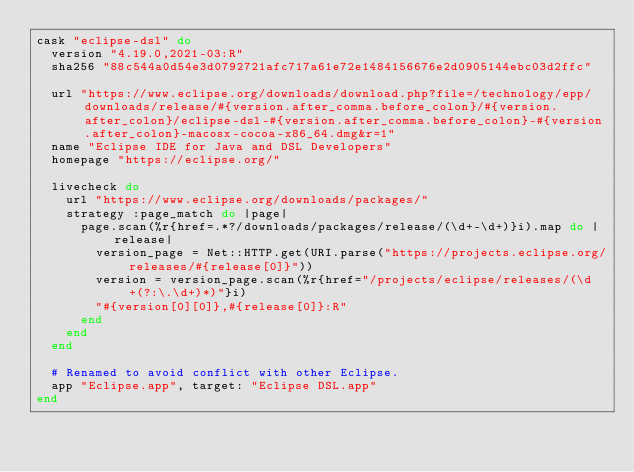Convert code to text. <code><loc_0><loc_0><loc_500><loc_500><_Ruby_>cask "eclipse-dsl" do
  version "4.19.0,2021-03:R"
  sha256 "88c544a0d54e3d0792721afc717a61e72e1484156676e2d0905144ebc03d2ffc"

  url "https://www.eclipse.org/downloads/download.php?file=/technology/epp/downloads/release/#{version.after_comma.before_colon}/#{version.after_colon}/eclipse-dsl-#{version.after_comma.before_colon}-#{version.after_colon}-macosx-cocoa-x86_64.dmg&r=1"
  name "Eclipse IDE for Java and DSL Developers"
  homepage "https://eclipse.org/"

  livecheck do
    url "https://www.eclipse.org/downloads/packages/"
    strategy :page_match do |page|
      page.scan(%r{href=.*?/downloads/packages/release/(\d+-\d+)}i).map do |release|
        version_page = Net::HTTP.get(URI.parse("https://projects.eclipse.org/releases/#{release[0]}"))
        version = version_page.scan(%r{href="/projects/eclipse/releases/(\d+(?:\.\d+)*)"}i)
        "#{version[0][0]},#{release[0]}:R"
      end
    end
  end

  # Renamed to avoid conflict with other Eclipse.
  app "Eclipse.app", target: "Eclipse DSL.app"
end
</code> 